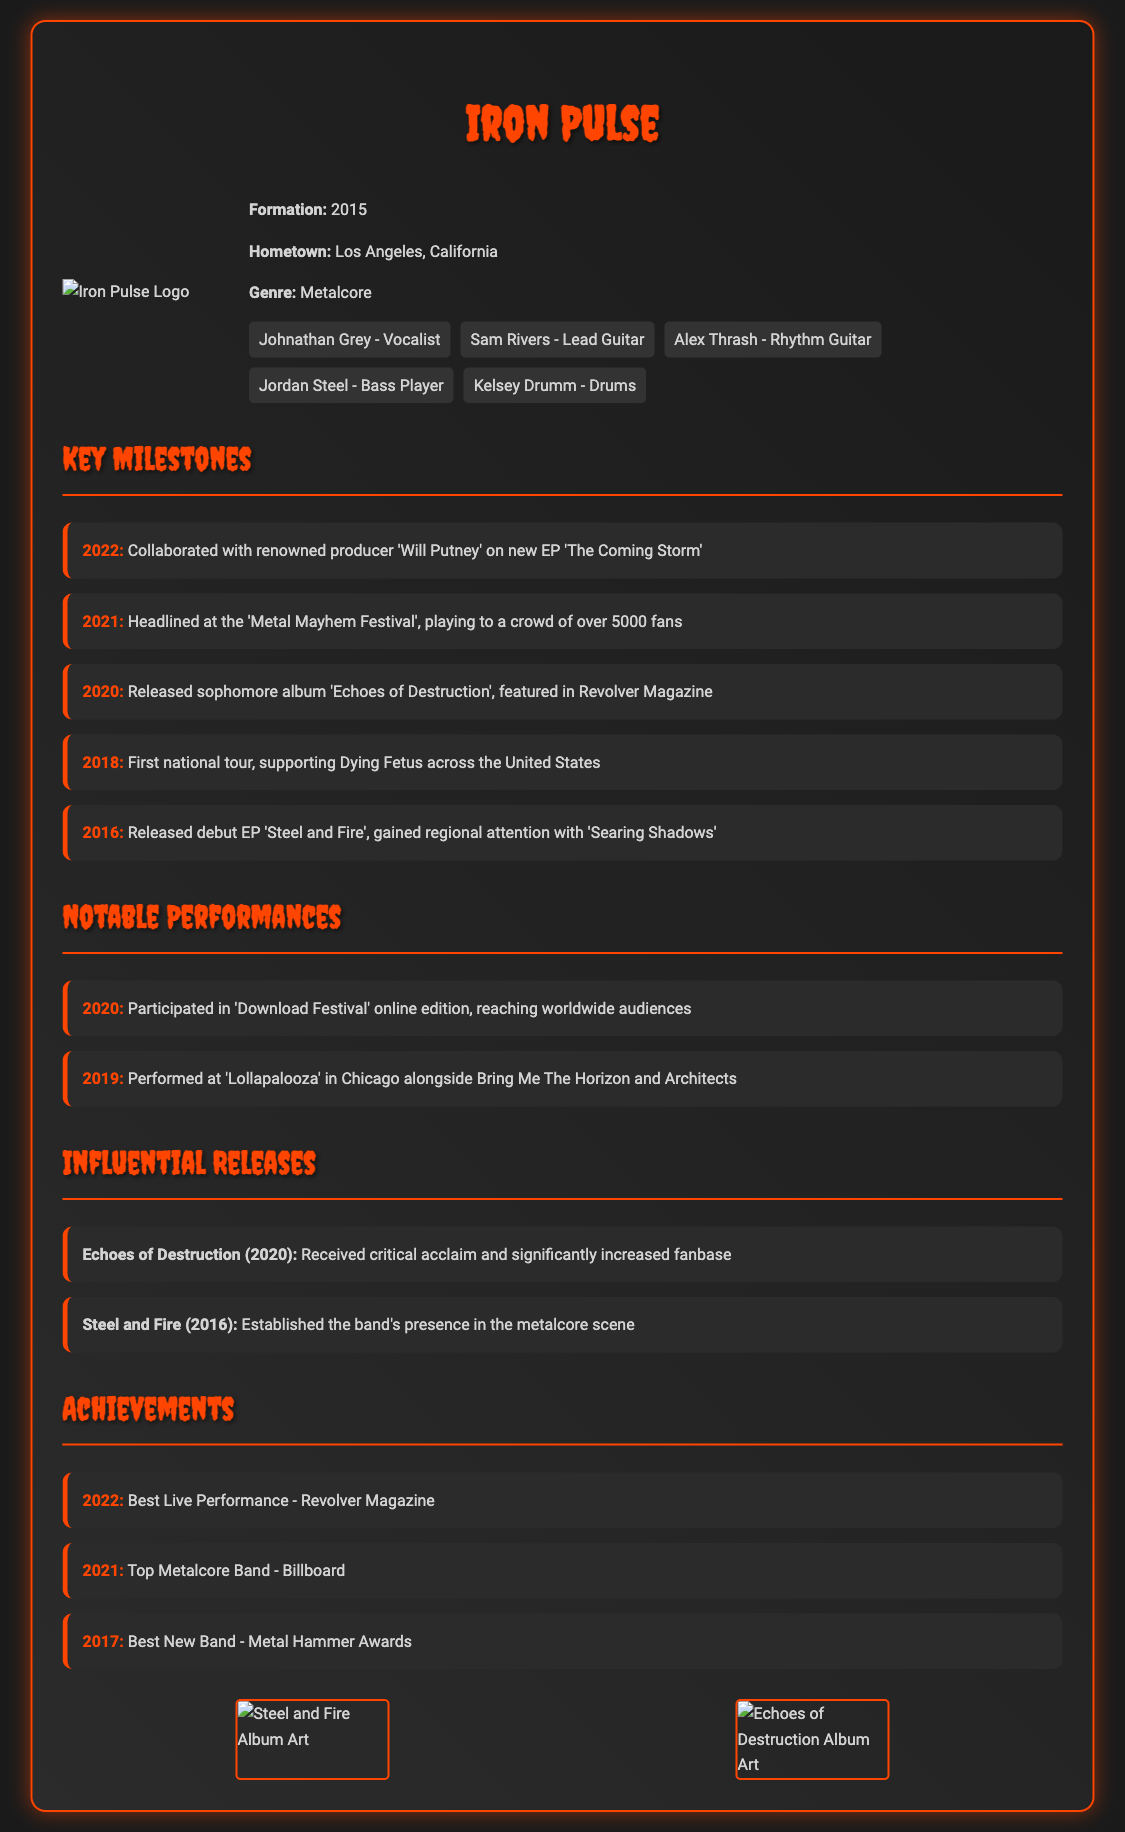What year was Iron Pulse formed? The document states that Iron Pulse was formed in 2015.
Answer: 2015 Who is the lead guitarist of Iron Pulse? The document lists "Sam Rivers" as the lead guitarist.
Answer: Sam Rivers What major festival did Iron Pulse headline in 2021? The document mentions that Iron Pulse headlined the "Metal Mayhem Festival" in 2021.
Answer: Metal Mayhem Festival What is the title of Iron Pulse's sophomore album? The document indicates that the sophomore album is titled "Echoes of Destruction."
Answer: Echoes of Destruction In what year did Iron Pulse win the Best New Band award? The document states that Iron Pulse won Best New Band in 2017.
Answer: 2017 Which producer did Iron Pulse collaborate with for their EP in 2022? The document states that Iron Pulse collaborated with producer "Will Putney" for their EP.
Answer: Will Putney How many albums are mentioned in the Influential Releases section? There are two albums listed in that section: "Echoes of Destruction" and "Steel and Fire."
Answer: Two What location is listed as Iron Pulse's hometown? The document mentions that the hometown of Iron Pulse is Los Angeles, California.
Answer: Los Angeles, California Who was the drummer for Iron Pulse? According to the document, "Kelsey Drumm" is identified as the drummer.
Answer: Kelsey Drumm 